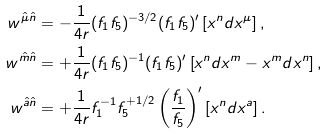<formula> <loc_0><loc_0><loc_500><loc_500>w ^ { \hat { \mu } \hat { n } } & = - \frac { 1 } { 4 r } ( f _ { 1 } f _ { 5 } ) ^ { - 3 / 2 } ( f _ { 1 } f _ { 5 } ) ^ { \prime } \left [ x ^ { n } d x ^ { \mu } \right ] , \\ w ^ { \hat { m } \hat { n } } & = + \frac { 1 } { 4 r } ( f _ { 1 } f _ { 5 } ) ^ { - 1 } ( f _ { 1 } f _ { 5 } ) ^ { \prime } \left [ x ^ { n } d x ^ { m } - x ^ { m } d x ^ { n } \right ] , \\ w ^ { \hat { a } \hat { n } } & = + \frac { 1 } { 4 r } f _ { 1 } ^ { - 1 } f _ { 5 } ^ { + 1 / 2 } \left ( \frac { f _ { 1 } } { f _ { 5 } } \right ) ^ { \prime } \left [ x ^ { n } d x ^ { a } \right ] .</formula> 